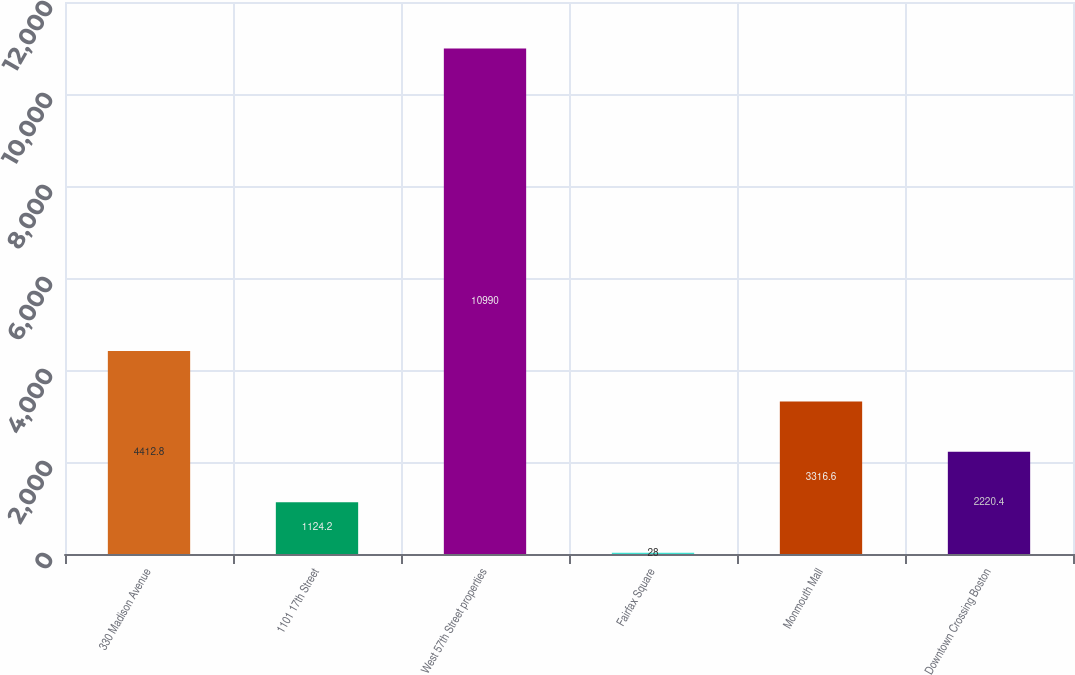Convert chart to OTSL. <chart><loc_0><loc_0><loc_500><loc_500><bar_chart><fcel>330 Madison Avenue<fcel>1101 17th Street<fcel>West 57th Street properties<fcel>Fairfax Square<fcel>Monmouth Mall<fcel>Downtown Crossing Boston<nl><fcel>4412.8<fcel>1124.2<fcel>10990<fcel>28<fcel>3316.6<fcel>2220.4<nl></chart> 